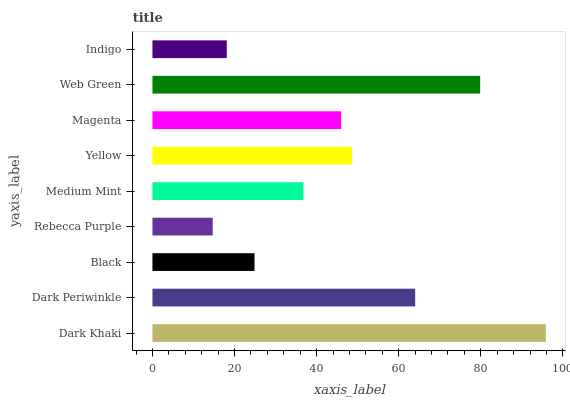Is Rebecca Purple the minimum?
Answer yes or no. Yes. Is Dark Khaki the maximum?
Answer yes or no. Yes. Is Dark Periwinkle the minimum?
Answer yes or no. No. Is Dark Periwinkle the maximum?
Answer yes or no. No. Is Dark Khaki greater than Dark Periwinkle?
Answer yes or no. Yes. Is Dark Periwinkle less than Dark Khaki?
Answer yes or no. Yes. Is Dark Periwinkle greater than Dark Khaki?
Answer yes or no. No. Is Dark Khaki less than Dark Periwinkle?
Answer yes or no. No. Is Magenta the high median?
Answer yes or no. Yes. Is Magenta the low median?
Answer yes or no. Yes. Is Yellow the high median?
Answer yes or no. No. Is Indigo the low median?
Answer yes or no. No. 